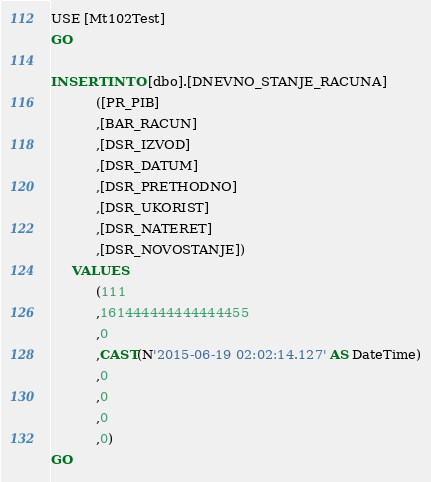Convert code to text. <code><loc_0><loc_0><loc_500><loc_500><_SQL_>USE [Mt102Test]
GO

INSERT INTO [dbo].[DNEVNO_STANJE_RACUNA]
           ([PR_PIB]
           ,[BAR_RACUN]
           ,[DSR_IZVOD]
           ,[DSR_DATUM]
           ,[DSR_PRETHODNO]
           ,[DSR_UKORIST]
           ,[DSR_NATERET]
           ,[DSR_NOVOSTANJE])
     VALUES
           (111
           ,161444444444444455
           ,0
           ,CAST(N'2015-06-19 02:02:14.127' AS DateTime)
           ,0
           ,0
           ,0
           ,0)
GO


</code> 